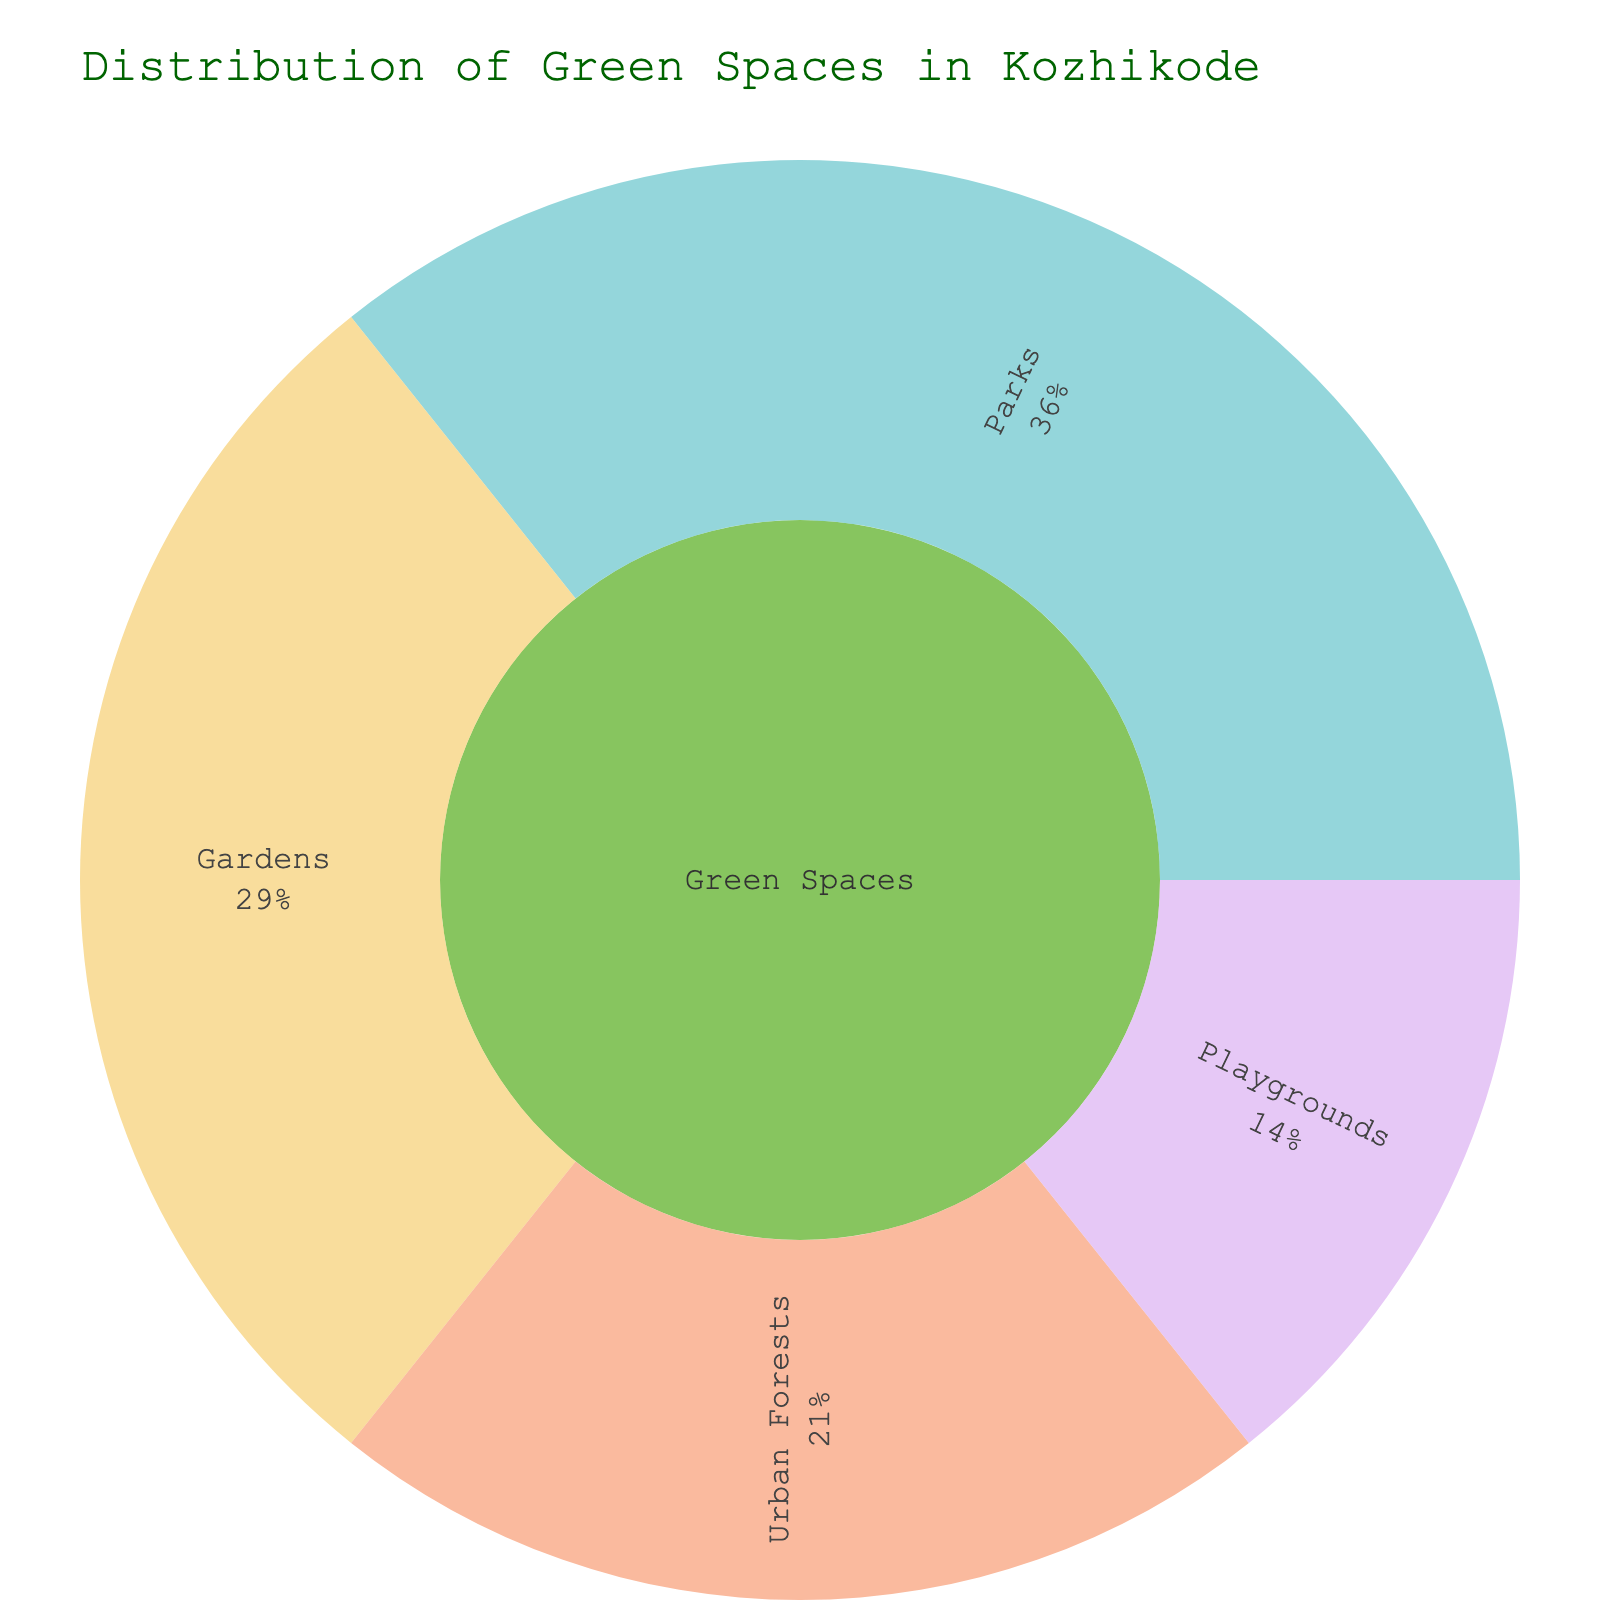How many types of green spaces are represented in the plot? The plot shows the main category "Green Spaces" which is divided into four subcategories. The types represented are Parks, Gardens, Urban Forests, and Playgrounds.
Answer: Four Which subcategory has the largest area? The plot shows that the largest portion of the Sunburst Plot belongs to Parks, indicating that they occupy the largest area.
Answer: Parks What percentage of the total green space area is occupied by Parks? Parks occupy a quadrant that states its percentage of the total parent area, which is 100 sq.m out of a total of 280 sq.m (100+80+60+40). This can be calculated as (100/280) * 100.
Answer: Approximately 35.7% What is the area size difference between Gardens and Playgrounds? Gardens have an area of 80 sq.m and Playgrounds have 40 sq.m. The difference is obtained by subtracting the smaller area from the larger one: 80 - 40.
Answer: 40 sq.m Which subcategory occupies the smallest area, and what is its size? By looking at the sizes of all subcategories, Playgrounds have the smallest area, which is listed as 40 sq.m.
Answer: Playgrounds, 40 sq.m How does the area of Urban Forests compare to that of Gardens? The plot shows that Urban Forests have an area of 60 sq.m, while Gardens have 80 sq.m. Urban Forests, therefore, have a smaller area.
Answer: Urban Forests have a smaller area If you combine Parks and Gardens, what is the total area they occupy? Adding the area of Parks (100 sq.m) and Gardens (80 sq.m) results in a total area of 180 sq.m.
Answer: 180 sq.m Which are larger: Playgrounds or Urban Forests? The sizes are shown in the plot, where Urban Forests (60 sq.m) are larger than Playgrounds (40 sq.m).
Answer: Urban Forests What percentage of the total green space is occupied by Urban Forests? Urban Forests have an area of 60 sq.m out of the total 280 sq.m. To find the percentage, use (60/280) * 100.
Answer: Approximately 21.4% Compare the total area of all green spaces to the area of Parks. The total area for all green spaces is 280 sq.m and for Parks is 100 sq.m. Parks make up a certain percentage of the total, computed as (100/280) * 100.
Answer: Approximately 35.7% 